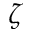<formula> <loc_0><loc_0><loc_500><loc_500>\zeta</formula> 